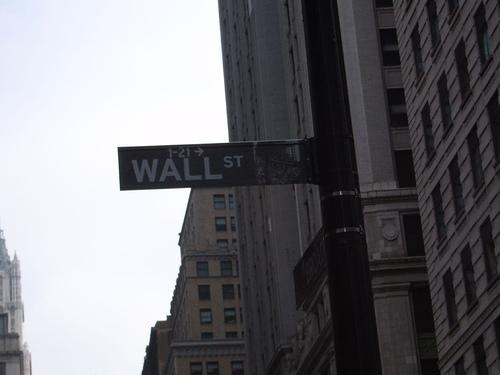What are the letters on the left?
Keep it brief. Wall. What is the green stuff on the other side of the window?
Quick response, please. Sign. What is the street name?
Quick response, please. Wall st. Is there a crane in the photo?
Quick response, please. No. What word is implied by the "I" on top of this sign?
Keep it brief. Interstate. What is the shape of the sign?
Concise answer only. Rectangle. Is there a clock?
Answer briefly. No. Is this sign in a big city?
Be succinct. Yes. Is the arrow pointing up or down?
Write a very short answer. Right. How many signs are there?
Keep it brief. 2. What monument is this?
Concise answer only. Wall st. What street is this?
Be succinct. Wall. What street is it?
Concise answer only. Wall. Are the lights on in the building?
Give a very brief answer. No. How tall is the pole?
Write a very short answer. Very tall. What color is the sky?
Concise answer only. White. What is the Name of the Street?
Keep it brief. Wall. What letter does the street name begin with?
Answer briefly. W. 